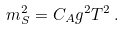<formula> <loc_0><loc_0><loc_500><loc_500>m _ { S } ^ { 2 } = C _ { A } g ^ { 2 } T ^ { 2 } \, .</formula> 